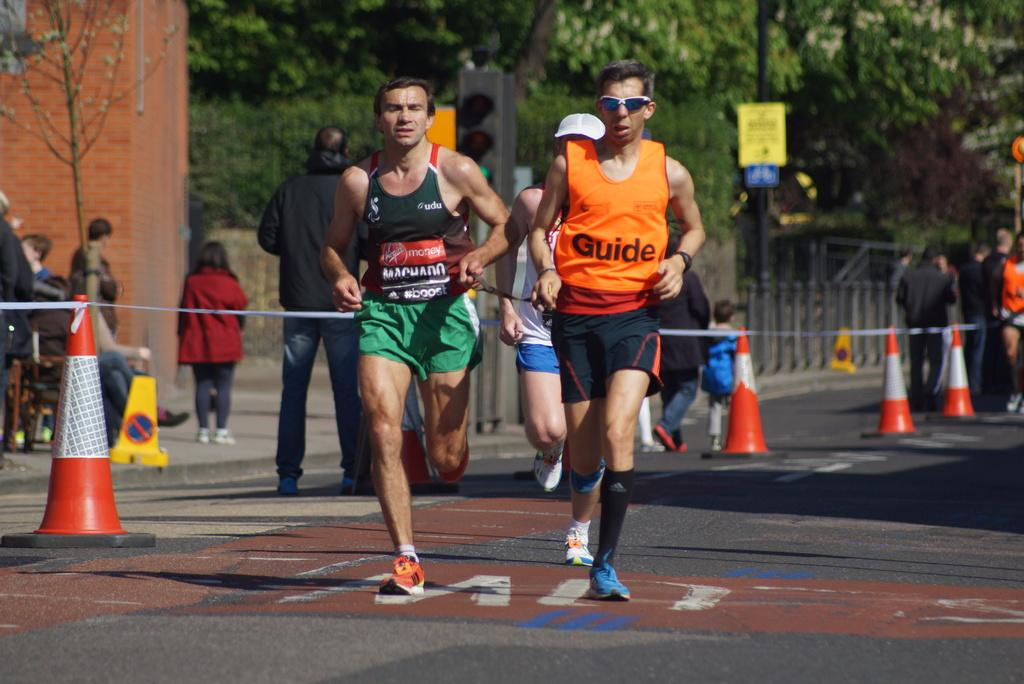<image>
Provide a brief description of the given image. Man wearing an orange jersey that says "Guide" is racing someone else. 